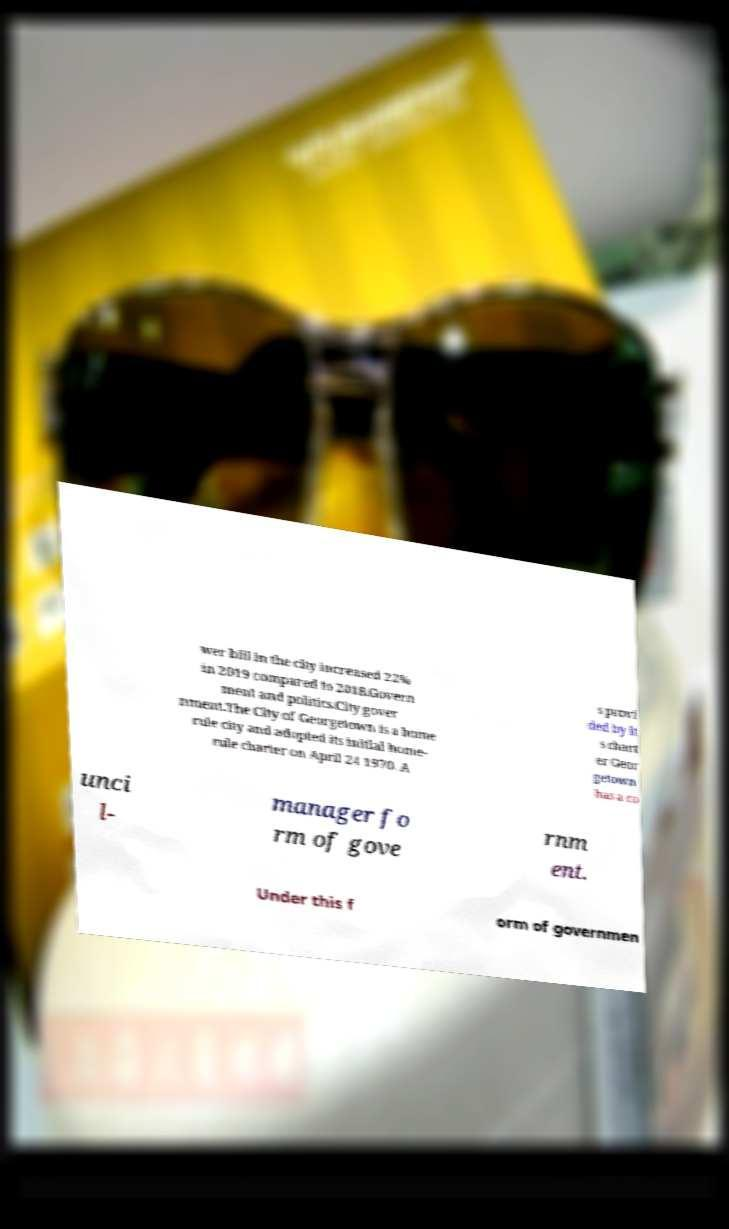Could you extract and type out the text from this image? wer bill in the city increased 22% in 2019 compared to 2018.Govern ment and politics.City gover nment.The City of Georgetown is a home rule city and adopted its initial home- rule charter on April 24 1970. A s provi ded by it s chart er Geor getown has a co unci l- manager fo rm of gove rnm ent. Under this f orm of governmen 